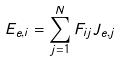<formula> <loc_0><loc_0><loc_500><loc_500>E _ { e , i } = \sum _ { j = 1 } ^ { N } F _ { i j } J _ { e , j }</formula> 